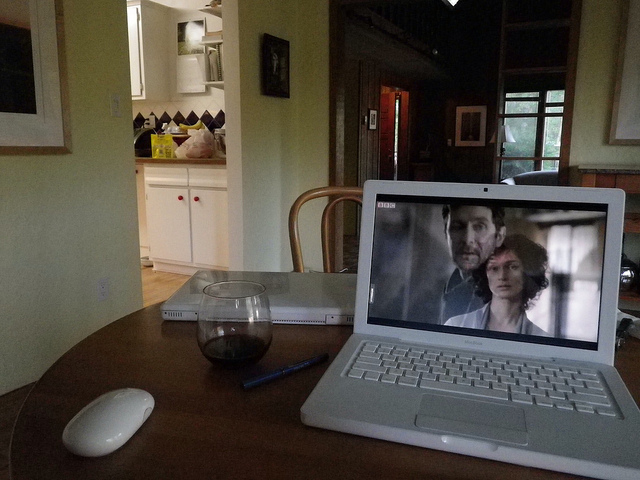<image>Which celebrity do you see? I am not sure which celebrity is in the image. The answer is ambiguous as there are several possibilities. Which celebrity do you see? I don't know which celebrity is seen in the image. It can be 'sigourney weaver', 'mia suvari', 'warren beatty', 'superman', 'matt damon', 'ralph fiennes', or 'brad pitt'. 